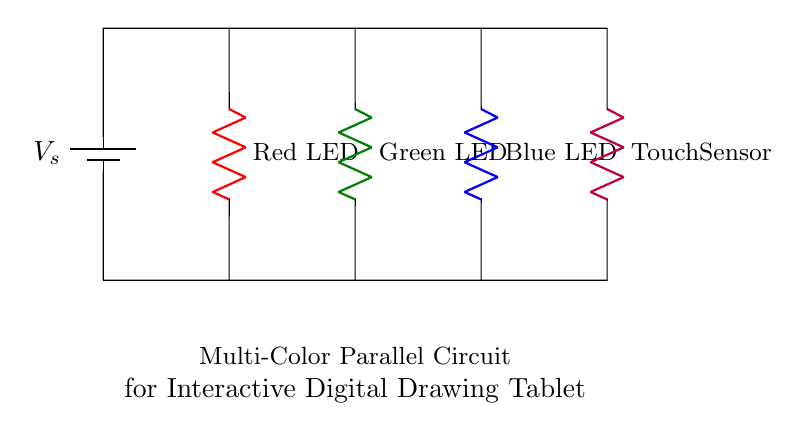What components are in this circuit? The circuit contains a battery, three LEDs (red, green, and blue), and a touch sensor. The basic function of the circuit involves these components being connected in parallel.
Answer: battery, three LEDs, touch sensor How many LEDs are present in the circuit? The circuit shows a total of three LEDs: one red, one green, and one blue, all operating in parallel with each other.
Answer: three What is the purpose of the touch sensor in this circuit? The touch sensor serves as an input device, likely to control the LEDs, enabling interactive use in a drawing tablet context. Its placement in a parallel arrangement indicates it can function independently of the LEDs.
Answer: control LEDs What happens to the current flow if one LED fails? Since the circuit is configured in parallel, if one LED fails, the current will continue to flow through the remaining LEDs, allowing them to function independently. This design supports reliability in usage.
Answer: continues flowing What color is the LED associated with the highest voltage in this circuit? While the schematic does not specify precise voltage levels for each LED, typically different colored LEDs might operate under different voltage requirements. However, in a standard parallel circuit, voltage across each component is the same as the supply. All LEDs here likely have the same supply voltage.
Answer: not applicable 